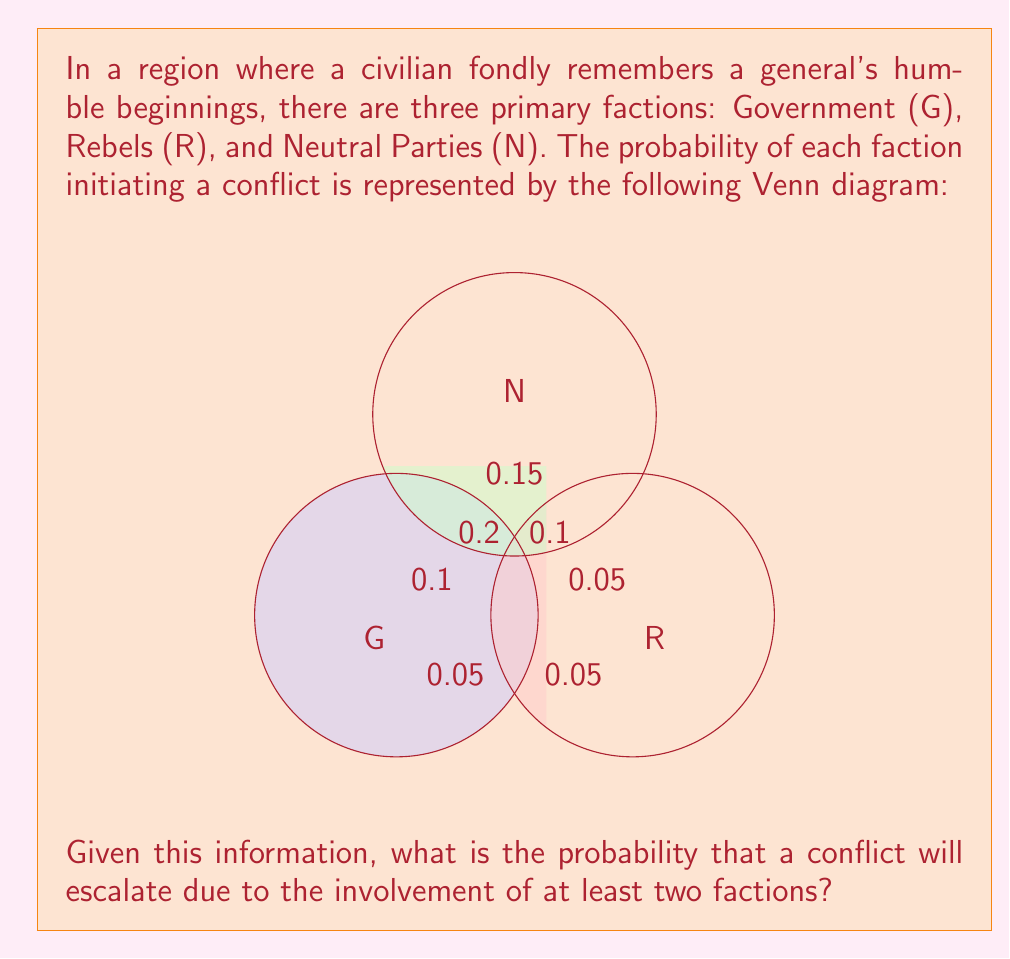What is the answer to this math problem? To solve this problem, we'll use set theory and the addition principle of probability. Let's break it down step-by-step:

1) First, we need to identify the probabilities of different combinations of factions initiating conflict:

   P(G ∩ R) = 0.05
   P(G ∩ N) = 0.2
   P(R ∩ N) = 0.1
   P(G ∩ R ∩ N) = 0.15

2) The question asks for the probability of at least two factions being involved. This includes the following cases:
   - G and R (but not N)
   - G and N (but not R)
   - R and N (but not G)
   - All three factions (G, R, and N)

3) We can calculate this using the addition principle:

   P(at least two) = P(G ∩ R) + P(G ∩ N) + P(R ∩ N) - 2P(G ∩ R ∩ N)

4) The reason we subtract 2P(G ∩ R ∩ N) is that the case where all three intersect is counted three times in the sum, so we need to subtract it twice to count it only once.

5) Plugging in the values:

   P(at least two) = 0.05 + 0.2 + 0.1 - 2(0.15)

6) Calculating:

   P(at least two) = 0.35 - 0.3 = 0.05

Therefore, the probability that a conflict will escalate due to the involvement of at least two factions is 0.05 or 5%.
Answer: 0.05 